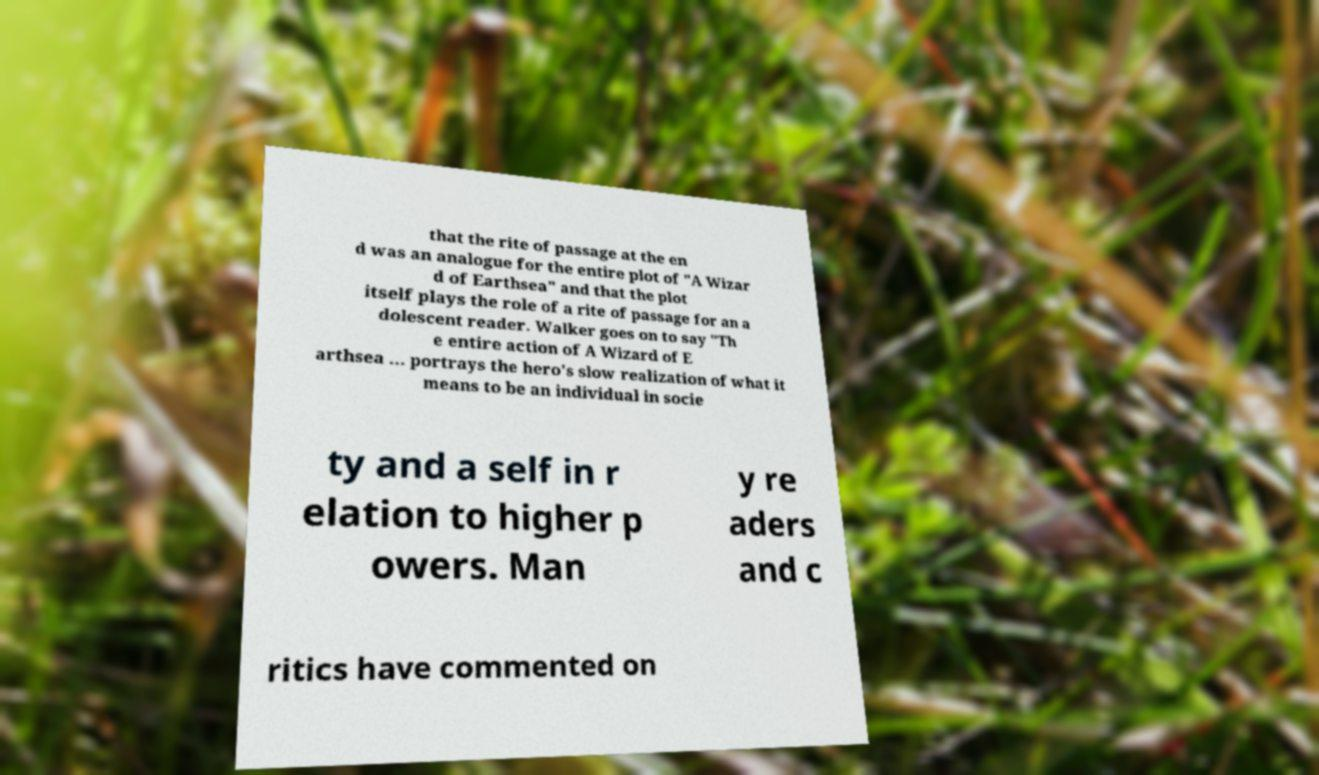What messages or text are displayed in this image? I need them in a readable, typed format. that the rite of passage at the en d was an analogue for the entire plot of "A Wizar d of Earthsea" and that the plot itself plays the role of a rite of passage for an a dolescent reader. Walker goes on to say "Th e entire action of A Wizard of E arthsea ... portrays the hero's slow realization of what it means to be an individual in socie ty and a self in r elation to higher p owers. Man y re aders and c ritics have commented on 